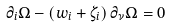Convert formula to latex. <formula><loc_0><loc_0><loc_500><loc_500>\partial _ { i } \Omega - \left ( w _ { i } + \zeta _ { i } \right ) \partial _ { \nu } \Omega = 0</formula> 